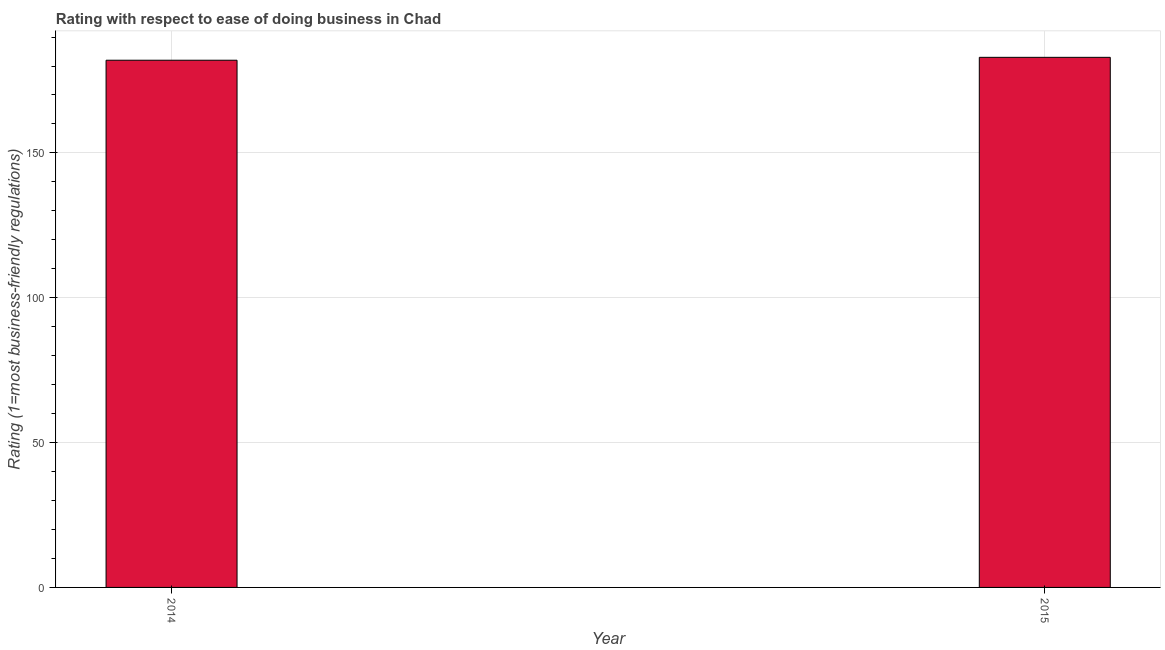Does the graph contain any zero values?
Keep it short and to the point. No. Does the graph contain grids?
Offer a very short reply. Yes. What is the title of the graph?
Your answer should be compact. Rating with respect to ease of doing business in Chad. What is the label or title of the X-axis?
Provide a short and direct response. Year. What is the label or title of the Y-axis?
Your answer should be very brief. Rating (1=most business-friendly regulations). What is the ease of doing business index in 2015?
Your answer should be compact. 183. Across all years, what is the maximum ease of doing business index?
Keep it short and to the point. 183. Across all years, what is the minimum ease of doing business index?
Give a very brief answer. 182. In which year was the ease of doing business index maximum?
Provide a short and direct response. 2015. What is the sum of the ease of doing business index?
Keep it short and to the point. 365. What is the average ease of doing business index per year?
Give a very brief answer. 182. What is the median ease of doing business index?
Your answer should be very brief. 182.5. In how many years, is the ease of doing business index greater than 70 ?
Provide a succinct answer. 2. Do a majority of the years between 2015 and 2014 (inclusive) have ease of doing business index greater than 80 ?
Make the answer very short. No. What is the ratio of the ease of doing business index in 2014 to that in 2015?
Keep it short and to the point. 0.99. Are all the bars in the graph horizontal?
Ensure brevity in your answer.  No. How many years are there in the graph?
Provide a succinct answer. 2. What is the difference between two consecutive major ticks on the Y-axis?
Offer a very short reply. 50. Are the values on the major ticks of Y-axis written in scientific E-notation?
Your response must be concise. No. What is the Rating (1=most business-friendly regulations) in 2014?
Offer a very short reply. 182. What is the Rating (1=most business-friendly regulations) of 2015?
Make the answer very short. 183. What is the difference between the Rating (1=most business-friendly regulations) in 2014 and 2015?
Provide a succinct answer. -1. 